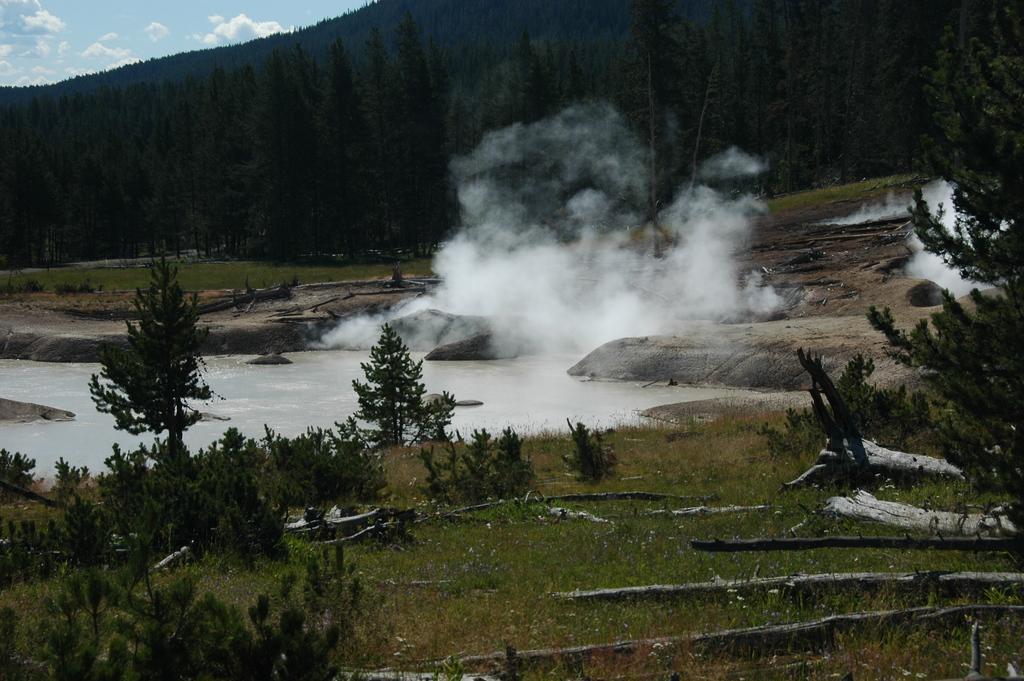Please provide a concise description of this image. At the bottom of the image on the ground there is grass, wooden logs and also there are small plants. Behind them there is water and also there is smoke. In the background there are trees. Behind them there is a hill. In the top left corner of the image there is sky with clouds. 